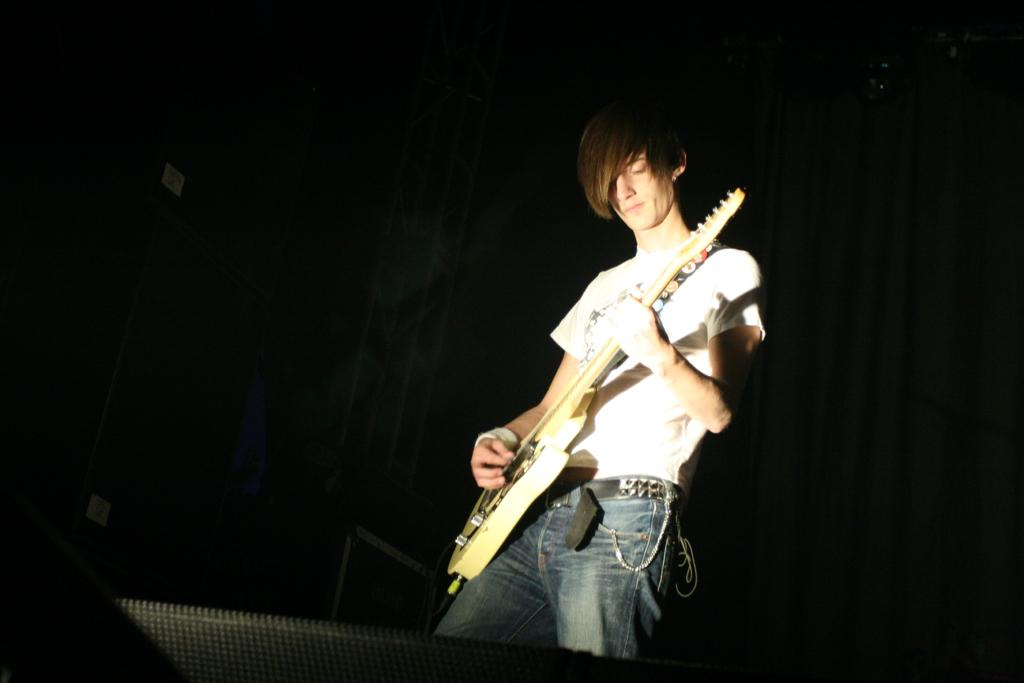What is the main activity being performed by the person in the image? The person is playing a guitar in the image. Can you describe the background of the image? The background of the image is dark. What objects can be seen besides the person playing the guitar? There are rods visible in the image. What color is the object at the bottom of the image? There is a black color object at the bottom of the image. Where is the garden located in the image? There is no garden present in the image. How many pockets can be seen on the person playing the guitar? The image does not show any pockets on the person playing the guitar. 